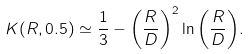Convert formula to latex. <formula><loc_0><loc_0><loc_500><loc_500>K ( R , 0 . 5 ) \simeq \frac { 1 } { 3 } - \left ( \frac { R } { D } \right ) ^ { 2 } \ln { \left ( \frac { R } { D } \right ) } .</formula> 